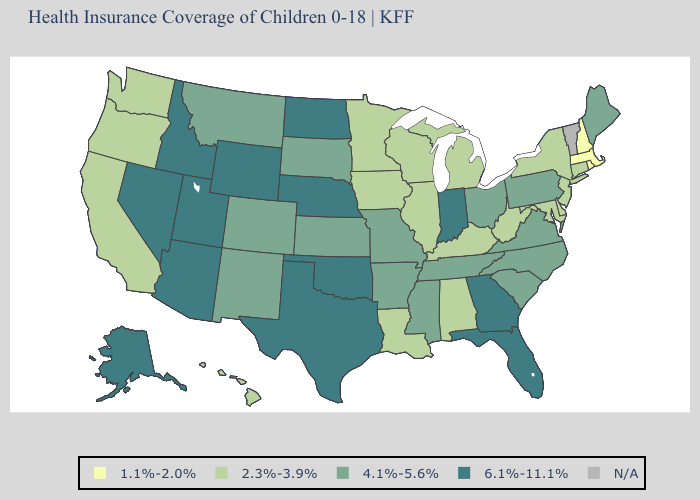Name the states that have a value in the range 4.1%-5.6%?
Quick response, please. Arkansas, Colorado, Kansas, Maine, Mississippi, Missouri, Montana, New Mexico, North Carolina, Ohio, Pennsylvania, South Carolina, South Dakota, Tennessee, Virginia. Name the states that have a value in the range 1.1%-2.0%?
Short answer required. Massachusetts, New Hampshire, Rhode Island. Name the states that have a value in the range 4.1%-5.6%?
Short answer required. Arkansas, Colorado, Kansas, Maine, Mississippi, Missouri, Montana, New Mexico, North Carolina, Ohio, Pennsylvania, South Carolina, South Dakota, Tennessee, Virginia. How many symbols are there in the legend?
Give a very brief answer. 5. Does Georgia have the lowest value in the South?
Answer briefly. No. Name the states that have a value in the range 1.1%-2.0%?
Give a very brief answer. Massachusetts, New Hampshire, Rhode Island. What is the highest value in the MidWest ?
Short answer required. 6.1%-11.1%. How many symbols are there in the legend?
Give a very brief answer. 5. What is the highest value in the USA?
Short answer required. 6.1%-11.1%. What is the value of Massachusetts?
Quick response, please. 1.1%-2.0%. Name the states that have a value in the range 2.3%-3.9%?
Be succinct. Alabama, California, Connecticut, Delaware, Hawaii, Illinois, Iowa, Kentucky, Louisiana, Maryland, Michigan, Minnesota, New Jersey, New York, Oregon, Washington, West Virginia, Wisconsin. What is the value of Florida?
Concise answer only. 6.1%-11.1%. 